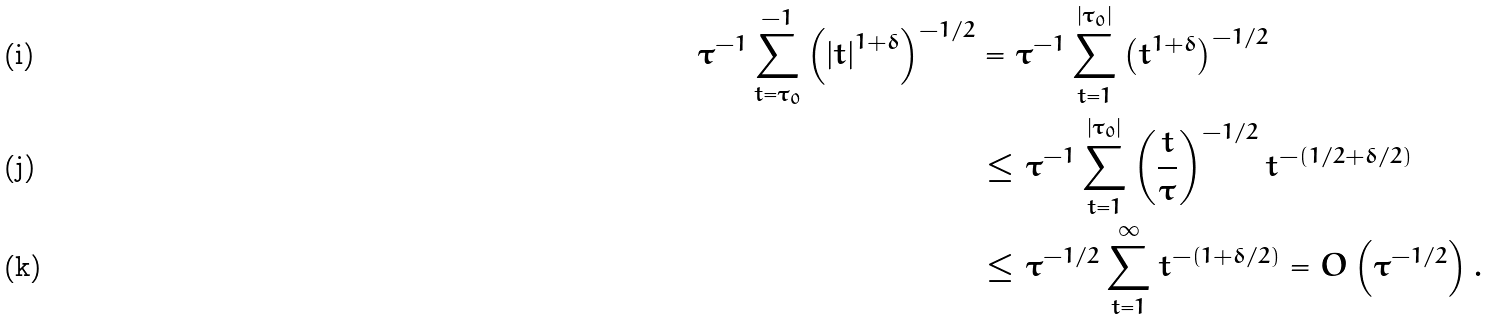<formula> <loc_0><loc_0><loc_500><loc_500>\tau ^ { - 1 } \sum _ { t = \tau _ { 0 } } ^ { - 1 } \left ( \left | t \right | ^ { 1 + \delta } \right ) ^ { - 1 / 2 } & = \tau ^ { - 1 } \sum _ { t = 1 } ^ { \left | \tau _ { 0 } \right | } \left ( t ^ { 1 + \delta } \right ) ^ { - 1 / 2 } \\ & \leq \tau ^ { - 1 } \sum _ { t = 1 } ^ { \left | \tau _ { 0 } \right | } \left ( \frac { t } { \tau } \right ) ^ { - 1 / 2 } t ^ { - \left ( 1 / 2 + \delta / 2 \right ) } \\ & \leq \tau ^ { - 1 / 2 } \sum _ { t = 1 } ^ { \infty } t ^ { - \left ( 1 + \delta / 2 \right ) } = O \left ( \tau ^ { - 1 / 2 } \right ) .</formula> 